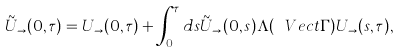<formula> <loc_0><loc_0><loc_500><loc_500>\tilde { U } _ { \rightarrow } ( 0 , \tau ) = U _ { \rightarrow } ( 0 , \tau ) + \int _ { 0 } ^ { \tau } d s \tilde { U } _ { \rightarrow } ( 0 , s ) \Lambda ( \ V e c t { \Gamma } ) U _ { \rightarrow } ( s , \tau ) ,</formula> 